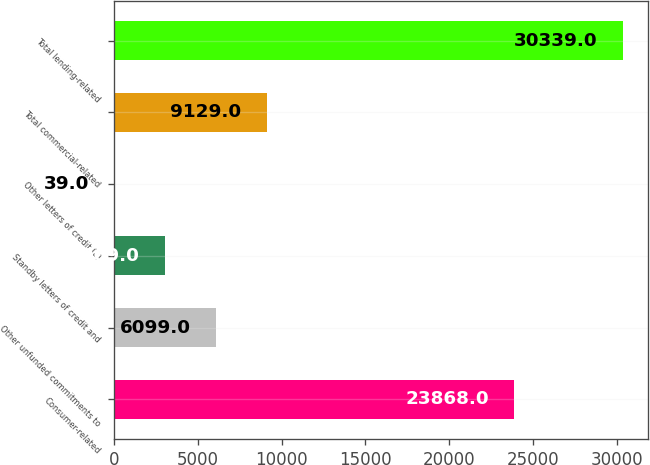Convert chart. <chart><loc_0><loc_0><loc_500><loc_500><bar_chart><fcel>Consumer-related<fcel>Other unfunded commitments to<fcel>Standby letters of credit and<fcel>Other letters of credit (a)<fcel>Total commercial-related<fcel>Total lending-related<nl><fcel>23868<fcel>6099<fcel>3069<fcel>39<fcel>9129<fcel>30339<nl></chart> 